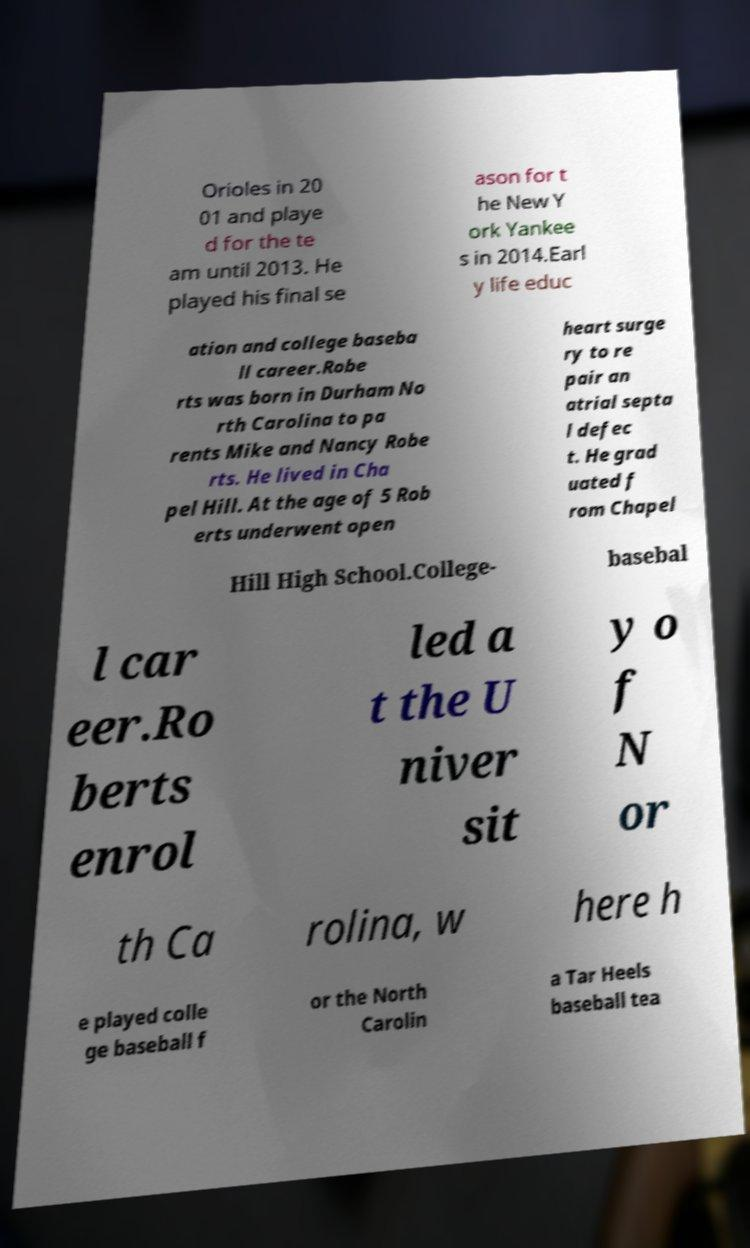Could you extract and type out the text from this image? Orioles in 20 01 and playe d for the te am until 2013. He played his final se ason for t he New Y ork Yankee s in 2014.Earl y life educ ation and college baseba ll career.Robe rts was born in Durham No rth Carolina to pa rents Mike and Nancy Robe rts. He lived in Cha pel Hill. At the age of 5 Rob erts underwent open heart surge ry to re pair an atrial septa l defec t. He grad uated f rom Chapel Hill High School.College- basebal l car eer.Ro berts enrol led a t the U niver sit y o f N or th Ca rolina, w here h e played colle ge baseball f or the North Carolin a Tar Heels baseball tea 